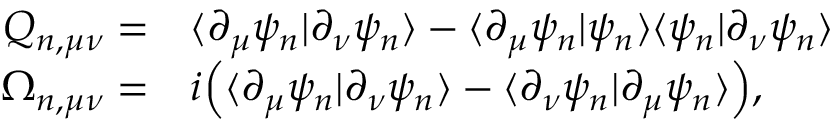Convert formula to latex. <formula><loc_0><loc_0><loc_500><loc_500>\begin{array} { r l } { Q _ { n , \mu \nu } = } & { \langle \partial _ { \mu } \psi _ { n } | \partial _ { \nu } \psi _ { n } \rangle - \langle \partial _ { \mu } \psi _ { n } | \psi _ { n } \rangle \langle \psi _ { n } | \partial _ { \nu } \psi _ { n } \rangle } \\ { \Omega _ { n , \mu \nu } = } & { i \left ( \langle \partial _ { \mu } \psi _ { n } | \partial _ { \nu } \psi _ { n } \rangle - \langle \partial _ { \nu } \psi _ { n } | \partial _ { \mu } \psi _ { n } \rangle \right ) , } \end{array}</formula> 